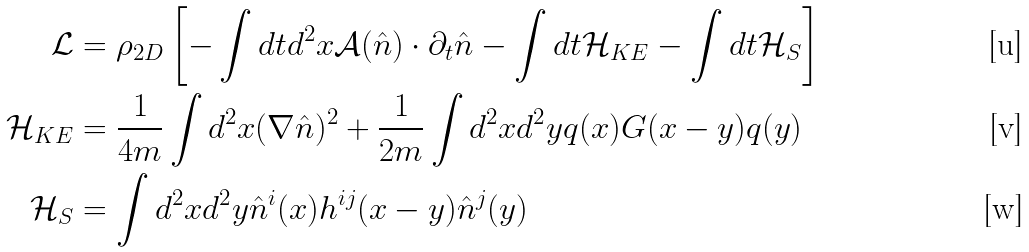Convert formula to latex. <formula><loc_0><loc_0><loc_500><loc_500>\mathcal { L } & = \rho _ { 2 D } \left [ - \int d t d ^ { 2 } x \mathcal { A } ( \hat { n } ) \cdot \partial _ { t } \hat { n } - \int d t \mathcal { H } _ { K E } - \int d t \mathcal { H } _ { S } \right ] \\ \mathcal { H } _ { K E } & = \frac { 1 } { 4 m } \int d ^ { 2 } x ( \nabla \hat { n } ) ^ { 2 } + \frac { 1 } { 2 m } \int d ^ { 2 } x d ^ { 2 } y q ( x ) G ( x - y ) q ( y ) \\ \mathcal { H } _ { S } & = \int d ^ { 2 } x d ^ { 2 } y \hat { n } ^ { i } ( x ) h ^ { i j } ( x - y ) \hat { n } ^ { j } ( y )</formula> 